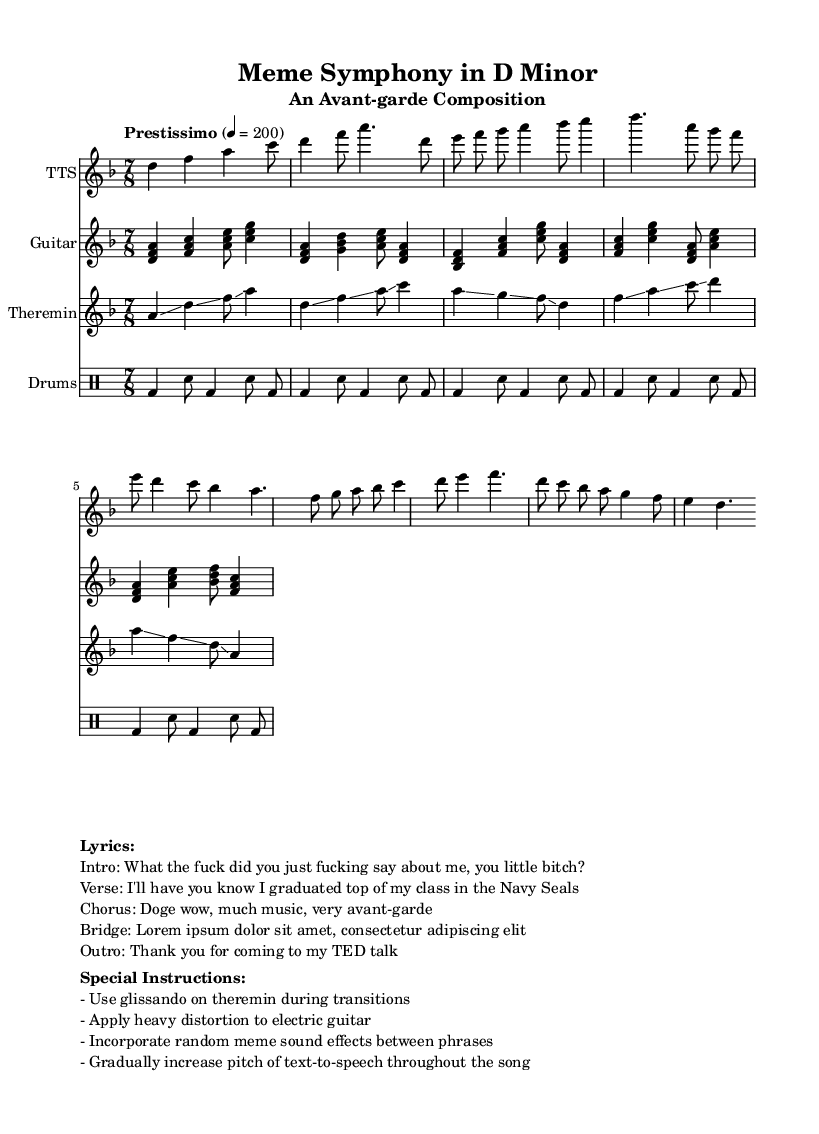What is the key signature of this music? The key signature is indicated at the beginning of the score. The "d" in "d minor" means that the piece is in the key of D minor, which has one flat.
Answer: D minor What is the time signature of this music? The time signature is found in the section labeled "\time" at the beginning of the global block. It is written as "7/8", meaning there are seven eighth notes in each measure.
Answer: 7/8 What is the tempo marking of this piece? The tempo is indicated by the word "Prestissimo" followed by a number in the global block, which indicates the speed of the piece. The marking specifies that the piece should be played very fast, with a metronome marking of 200 beats per minute.
Answer: Prestissimo How many unique sections does the composition have? The composition includes multiple labeled sections: Intro, Verse, Chorus, Bridge, and Outro. Each section is distinct and serves a specific role within the framework of the piece. By counting each of those sections, we find there are five unique sections.
Answer: 5 What special instruction is given for the theremin? In the special instructions section of the score, it specifically states to "Use glissando on theremin during transitions." This indicates how the theremin should be played to enhance the piece's avant-garde character.
Answer: Use glissando What wording is used in the Chorus section of the lyrics? The lyrics for the Chorus are provided in the markup section, directly under the title "Lyrics." It states, "Doge wow, much music, very avant-garde," which encapsulates the absurdist humor often found in meme culture.
Answer: Doge wow, much music, very avant-garde 